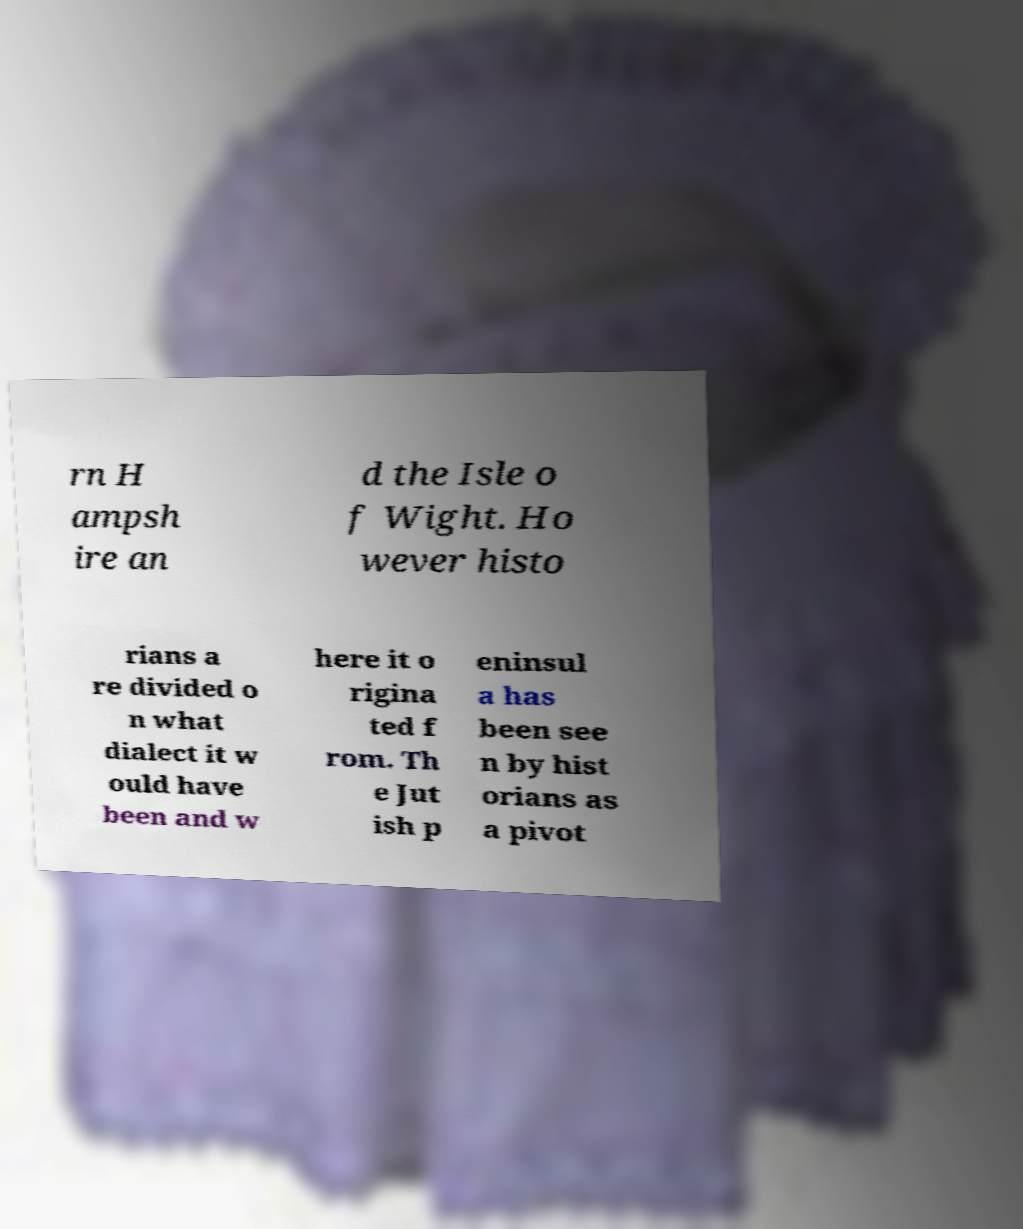What messages or text are displayed in this image? I need them in a readable, typed format. rn H ampsh ire an d the Isle o f Wight. Ho wever histo rians a re divided o n what dialect it w ould have been and w here it o rigina ted f rom. Th e Jut ish p eninsul a has been see n by hist orians as a pivot 